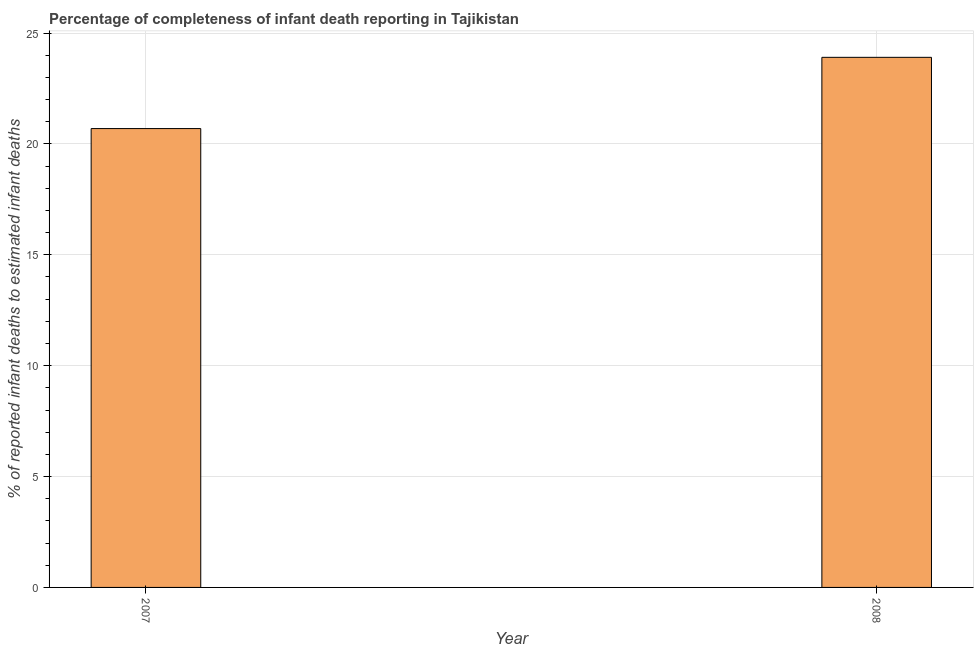Does the graph contain any zero values?
Give a very brief answer. No. What is the title of the graph?
Keep it short and to the point. Percentage of completeness of infant death reporting in Tajikistan. What is the label or title of the X-axis?
Your answer should be very brief. Year. What is the label or title of the Y-axis?
Make the answer very short. % of reported infant deaths to estimated infant deaths. What is the completeness of infant death reporting in 2008?
Keep it short and to the point. 23.9. Across all years, what is the maximum completeness of infant death reporting?
Your response must be concise. 23.9. Across all years, what is the minimum completeness of infant death reporting?
Your response must be concise. 20.69. In which year was the completeness of infant death reporting maximum?
Ensure brevity in your answer.  2008. What is the sum of the completeness of infant death reporting?
Offer a very short reply. 44.59. What is the difference between the completeness of infant death reporting in 2007 and 2008?
Offer a very short reply. -3.21. What is the average completeness of infant death reporting per year?
Ensure brevity in your answer.  22.3. What is the median completeness of infant death reporting?
Your response must be concise. 22.3. In how many years, is the completeness of infant death reporting greater than 12 %?
Provide a succinct answer. 2. What is the ratio of the completeness of infant death reporting in 2007 to that in 2008?
Make the answer very short. 0.87. Is the completeness of infant death reporting in 2007 less than that in 2008?
Provide a short and direct response. Yes. In how many years, is the completeness of infant death reporting greater than the average completeness of infant death reporting taken over all years?
Offer a very short reply. 1. How many bars are there?
Provide a short and direct response. 2. What is the % of reported infant deaths to estimated infant deaths in 2007?
Make the answer very short. 20.69. What is the % of reported infant deaths to estimated infant deaths of 2008?
Offer a very short reply. 23.9. What is the difference between the % of reported infant deaths to estimated infant deaths in 2007 and 2008?
Keep it short and to the point. -3.21. What is the ratio of the % of reported infant deaths to estimated infant deaths in 2007 to that in 2008?
Your answer should be very brief. 0.87. 